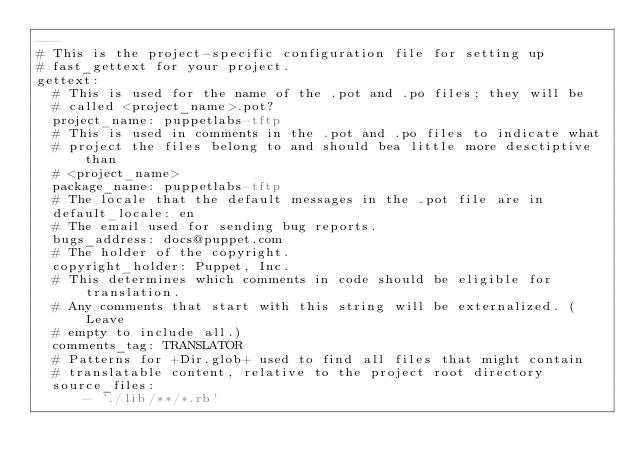Convert code to text. <code><loc_0><loc_0><loc_500><loc_500><_YAML_>---
# This is the project-specific configuration file for setting up
# fast_gettext for your project.
gettext:
  # This is used for the name of the .pot and .po files; they will be
  # called <project_name>.pot?
  project_name: puppetlabs-tftp
  # This is used in comments in the .pot and .po files to indicate what
  # project the files belong to and should bea little more desctiptive than
  # <project_name>
  package_name: puppetlabs-tftp
  # The locale that the default messages in the .pot file are in
  default_locale: en
  # The email used for sending bug reports.
  bugs_address: docs@puppet.com
  # The holder of the copyright.
  copyright_holder: Puppet, Inc.
  # This determines which comments in code should be eligible for translation.
  # Any comments that start with this string will be externalized. (Leave
  # empty to include all.)
  comments_tag: TRANSLATOR
  # Patterns for +Dir.glob+ used to find all files that might contain
  # translatable content, relative to the project root directory
  source_files:
      - './lib/**/*.rb'
  
</code> 